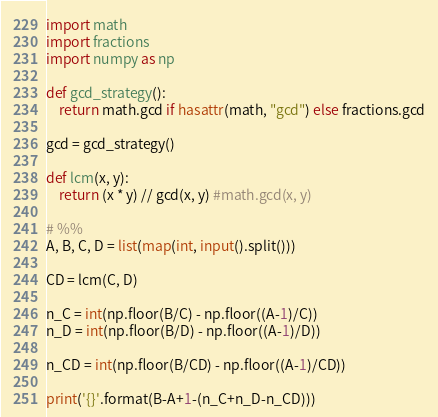Convert code to text. <code><loc_0><loc_0><loc_500><loc_500><_Python_>import math
import fractions
import numpy as np

def gcd_strategy():
    return math.gcd if hasattr(math, "gcd") else fractions.gcd

gcd = gcd_strategy()

def lcm(x, y):
    return (x * y) // gcd(x, y) #math.gcd(x, y)

# %%
A, B, C, D = list(map(int, input().split()))
    
CD = lcm(C, D) 

n_C = int(np.floor(B/C) - np.floor((A-1)/C))
n_D = int(np.floor(B/D) - np.floor((A-1)/D))

n_CD = int(np.floor(B/CD) - np.floor((A-1)/CD))

print('{}'.format(B-A+1-(n_C+n_D-n_CD)))
</code> 